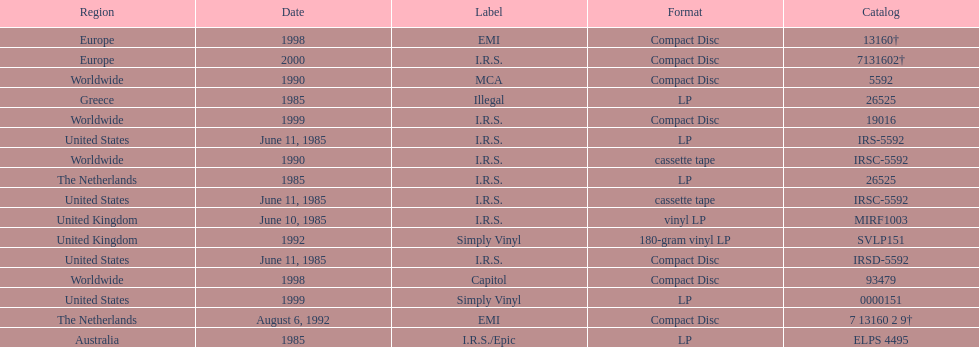How many more releases were in compact disc format than cassette tape? 5. 